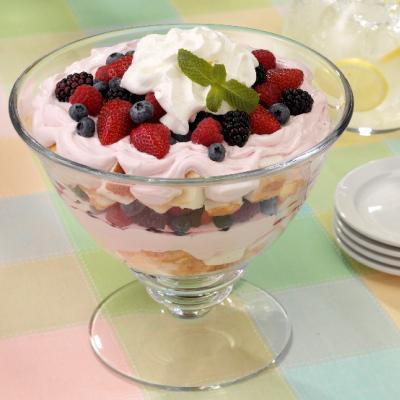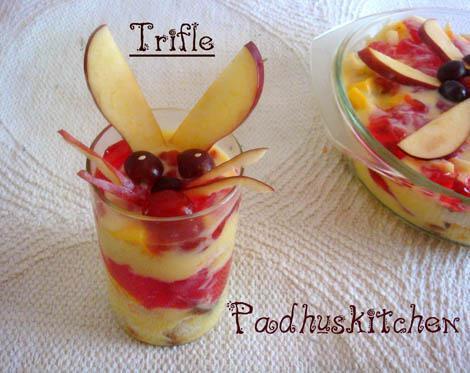The first image is the image on the left, the second image is the image on the right. Considering the images on both sides, is "The image to the right is in a cup instead of a bowl." valid? Answer yes or no. Yes. 